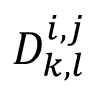Convert formula to latex. <formula><loc_0><loc_0><loc_500><loc_500>D _ { k , l } ^ { i , j }</formula> 